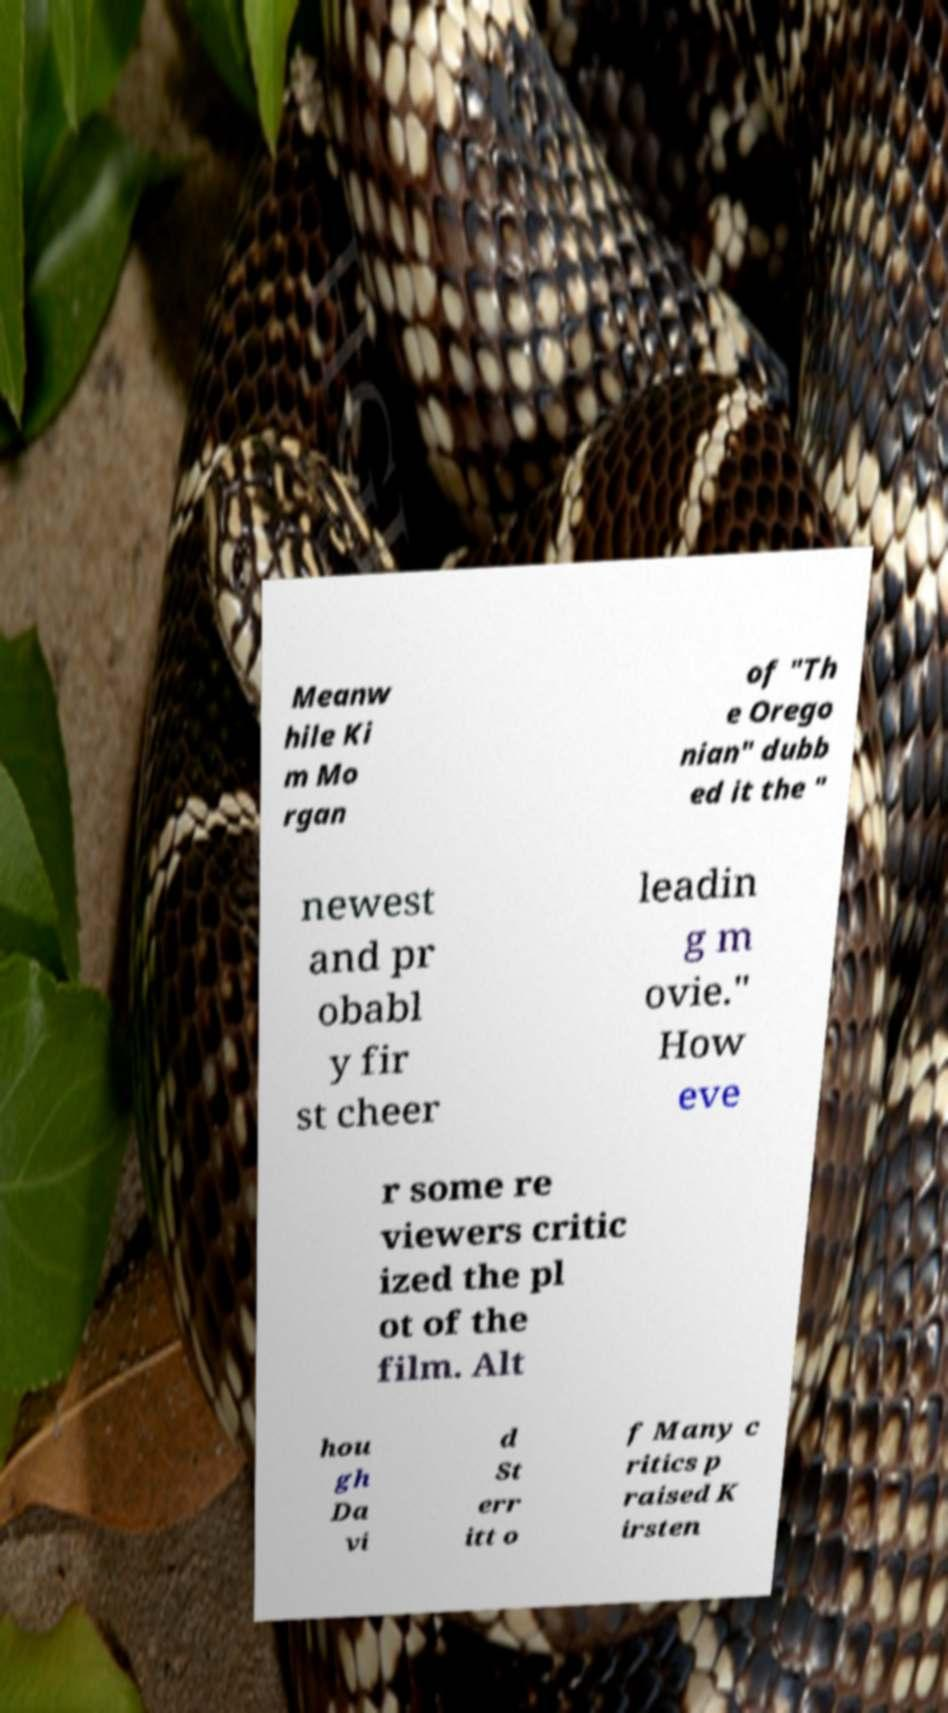Can you read and provide the text displayed in the image?This photo seems to have some interesting text. Can you extract and type it out for me? Meanw hile Ki m Mo rgan of "Th e Orego nian" dubb ed it the " newest and pr obabl y fir st cheer leadin g m ovie." How eve r some re viewers critic ized the pl ot of the film. Alt hou gh Da vi d St err itt o f Many c ritics p raised K irsten 